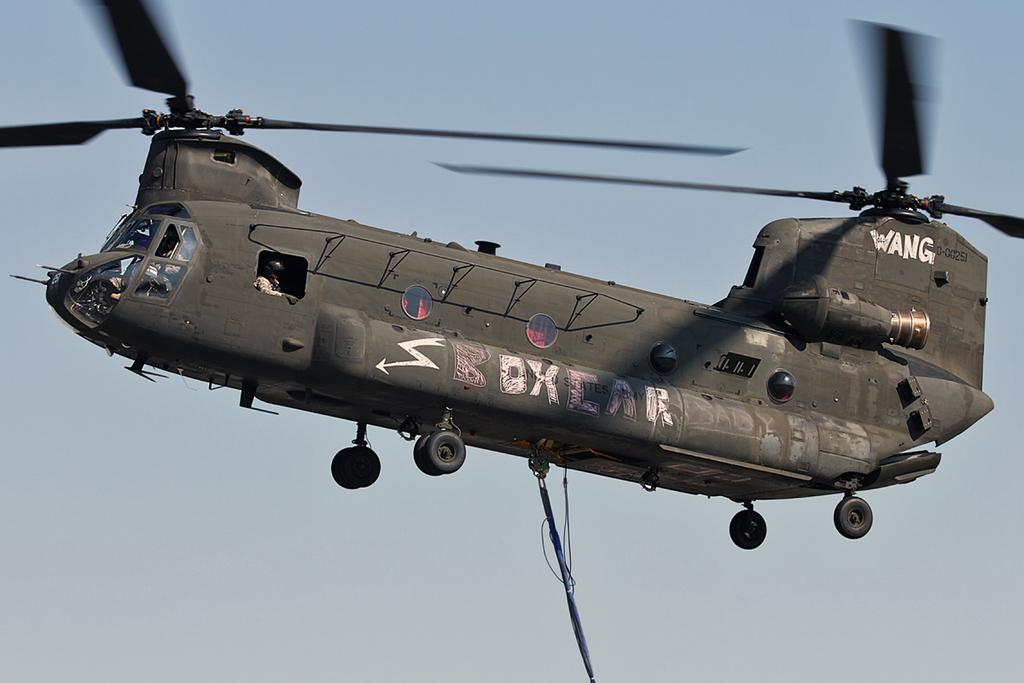What word is written on the bottom side panel?
Give a very brief answer. Boxcar. What is written by the rear propeller?
Your response must be concise. Wang. 